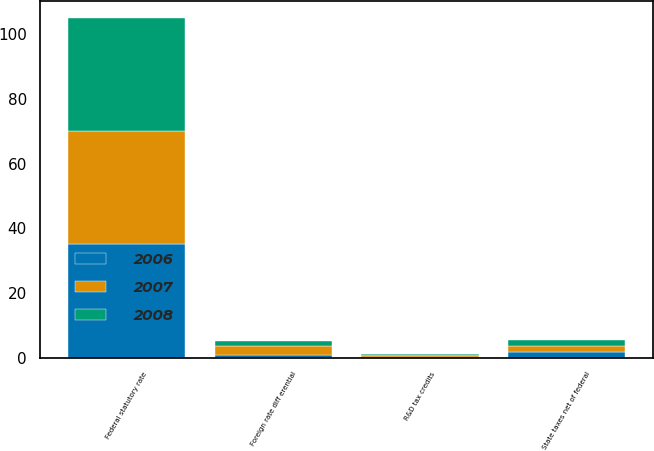Convert chart to OTSL. <chart><loc_0><loc_0><loc_500><loc_500><stacked_bar_chart><ecel><fcel>Federal statutory rate<fcel>Foreign rate diff erential<fcel>R&D tax credits<fcel>State taxes net of federal<nl><fcel>2007<fcel>35<fcel>2.54<fcel>0.41<fcel>2.02<nl><fcel>2008<fcel>35<fcel>1.66<fcel>0.44<fcel>1.93<nl><fcel>2006<fcel>35<fcel>0.97<fcel>0.36<fcel>1.67<nl></chart> 